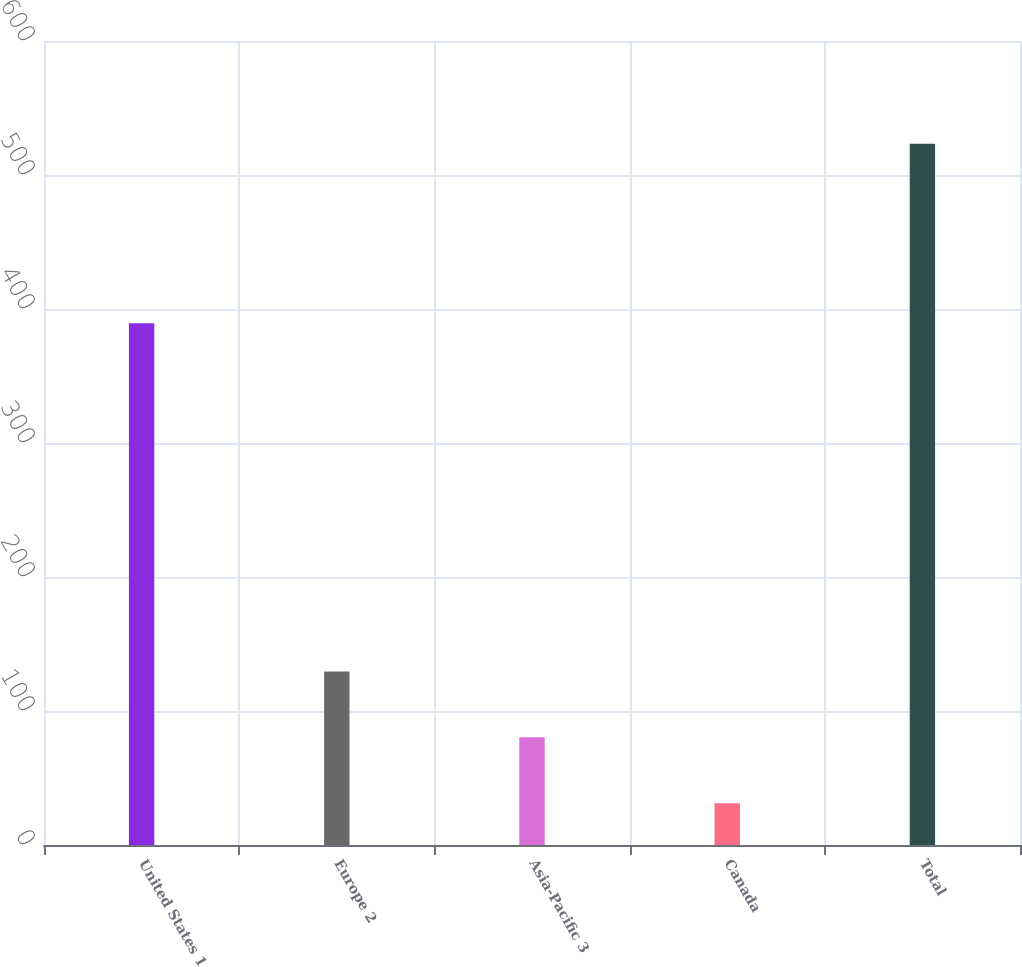Convert chart to OTSL. <chart><loc_0><loc_0><loc_500><loc_500><bar_chart><fcel>United States 1<fcel>Europe 2<fcel>Asia-Pacific 3<fcel>Canada<fcel>Total<nl><fcel>389.3<fcel>129.56<fcel>80.33<fcel>31.1<fcel>523.4<nl></chart> 